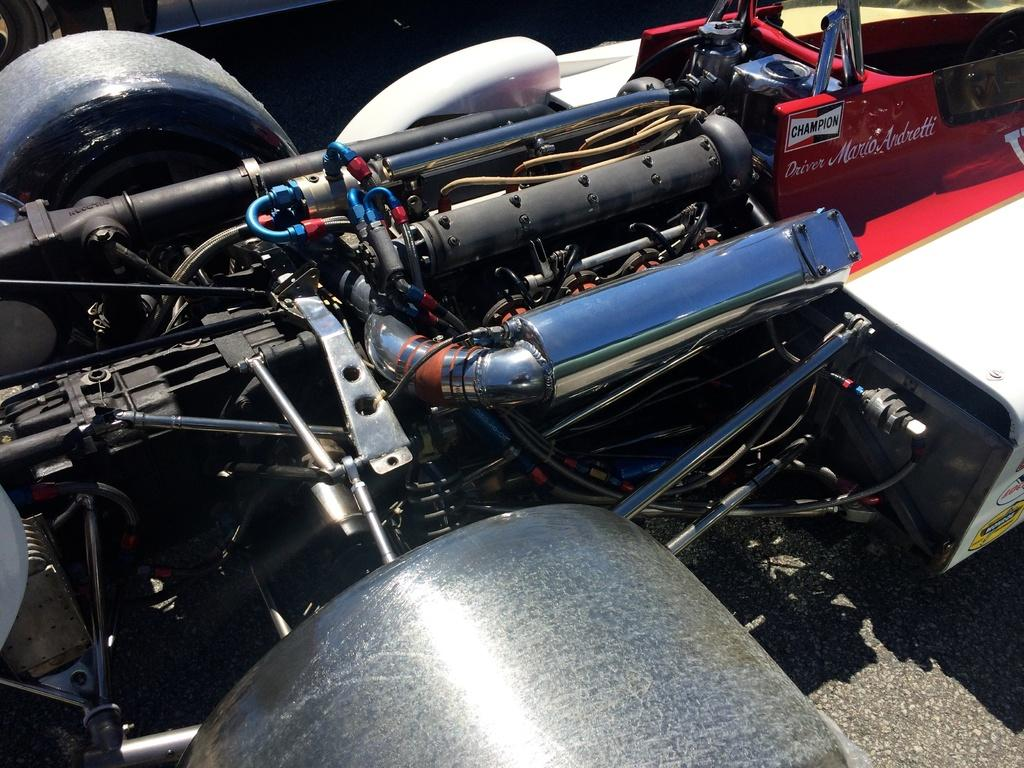What is the main subject of the image? There is a vehicle in the image. What else can be seen in the image besides the vehicle? There are wires in the image. Can you describe any specific parts of the vehicle that are visible? There are parts of the vehicle visible in the image. Is there any text present on the vehicle? Yes, there is text on a part of the vehicle. Can you tell me how many frogs are sitting on the hood of the vehicle in the image? There are no frogs present on the vehicle in the image. What type of metal is used to construct the vehicle? The type of metal used to construct the vehicle is not mentioned in the image. 